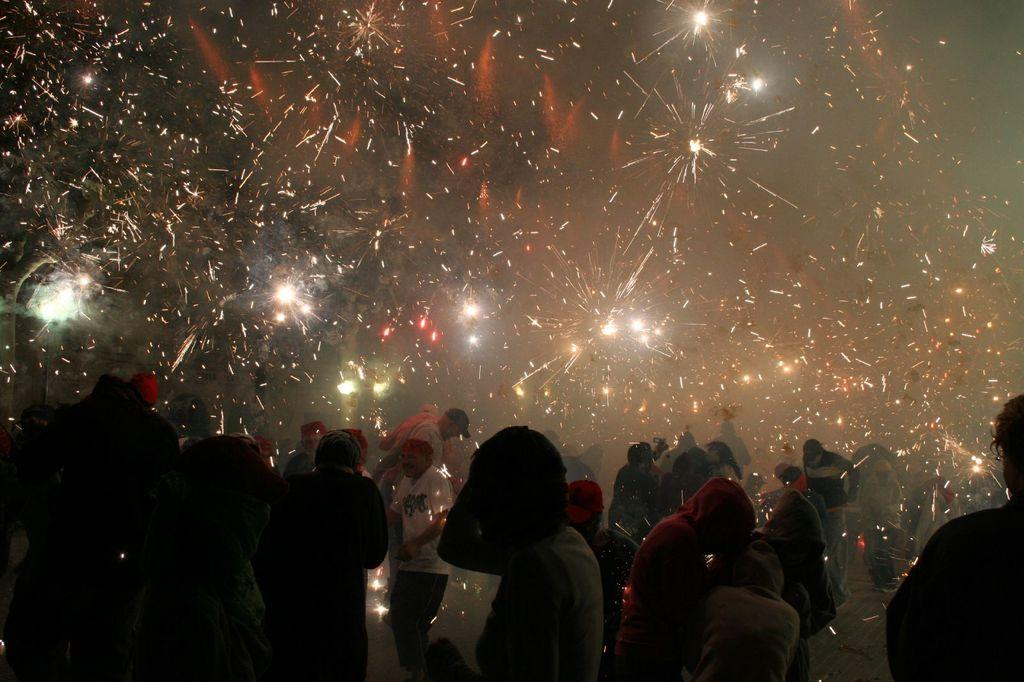How many people are in the image? There are many people in the image. What are the people in the image doing? The people are standing and burning crackers. What type of battle is taking place in the image? There is no battle present in the image; the people are standing and burning crackers. Can you see any goats or ice in the image? There are no goats or ice present in the image. 